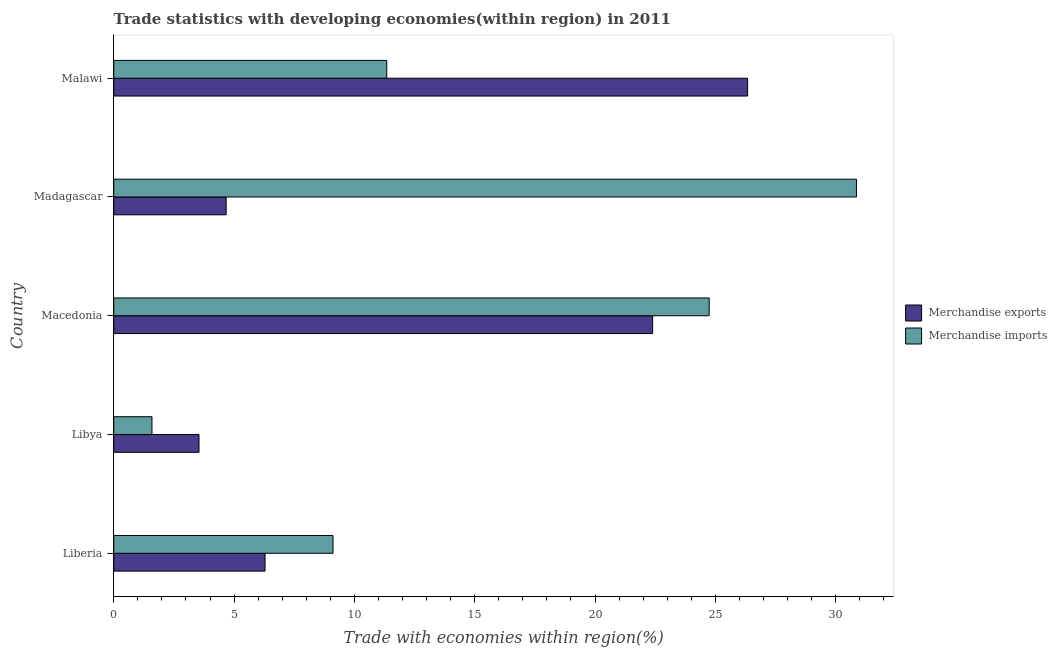How many groups of bars are there?
Make the answer very short. 5. Are the number of bars on each tick of the Y-axis equal?
Offer a terse response. Yes. What is the label of the 4th group of bars from the top?
Ensure brevity in your answer.  Libya. In how many cases, is the number of bars for a given country not equal to the number of legend labels?
Your answer should be very brief. 0. What is the merchandise imports in Malawi?
Your answer should be very brief. 11.35. Across all countries, what is the maximum merchandise imports?
Your answer should be very brief. 30.87. Across all countries, what is the minimum merchandise imports?
Provide a succinct answer. 1.59. In which country was the merchandise exports maximum?
Offer a very short reply. Malawi. In which country was the merchandise exports minimum?
Offer a terse response. Libya. What is the total merchandise exports in the graph?
Offer a terse response. 63.24. What is the difference between the merchandise exports in Liberia and that in Madagascar?
Offer a very short reply. 1.62. What is the difference between the merchandise exports in Libya and the merchandise imports in Macedonia?
Offer a very short reply. -21.2. What is the average merchandise exports per country?
Your answer should be compact. 12.65. What is the difference between the merchandise imports and merchandise exports in Macedonia?
Your response must be concise. 2.35. In how many countries, is the merchandise exports greater than 16 %?
Your response must be concise. 2. What is the ratio of the merchandise imports in Libya to that in Malawi?
Make the answer very short. 0.14. Is the merchandise imports in Libya less than that in Madagascar?
Provide a succinct answer. Yes. What is the difference between the highest and the second highest merchandise imports?
Your answer should be very brief. 6.12. What is the difference between the highest and the lowest merchandise imports?
Provide a succinct answer. 29.28. In how many countries, is the merchandise imports greater than the average merchandise imports taken over all countries?
Your response must be concise. 2. Is the sum of the merchandise exports in Liberia and Libya greater than the maximum merchandise imports across all countries?
Ensure brevity in your answer.  No. What does the 1st bar from the bottom in Madagascar represents?
Keep it short and to the point. Merchandise exports. How many countries are there in the graph?
Keep it short and to the point. 5. Are the values on the major ticks of X-axis written in scientific E-notation?
Your answer should be very brief. No. Does the graph contain grids?
Your answer should be compact. No. Where does the legend appear in the graph?
Provide a succinct answer. Center right. How many legend labels are there?
Offer a terse response. 2. How are the legend labels stacked?
Make the answer very short. Vertical. What is the title of the graph?
Provide a short and direct response. Trade statistics with developing economies(within region) in 2011. What is the label or title of the X-axis?
Your answer should be compact. Trade with economies within region(%). What is the label or title of the Y-axis?
Your answer should be compact. Country. What is the Trade with economies within region(%) of Merchandise exports in Liberia?
Give a very brief answer. 6.29. What is the Trade with economies within region(%) of Merchandise imports in Liberia?
Provide a short and direct response. 9.11. What is the Trade with economies within region(%) of Merchandise exports in Libya?
Make the answer very short. 3.54. What is the Trade with economies within region(%) of Merchandise imports in Libya?
Make the answer very short. 1.59. What is the Trade with economies within region(%) of Merchandise exports in Macedonia?
Give a very brief answer. 22.39. What is the Trade with economies within region(%) of Merchandise imports in Macedonia?
Provide a succinct answer. 24.75. What is the Trade with economies within region(%) of Merchandise exports in Madagascar?
Make the answer very short. 4.67. What is the Trade with economies within region(%) in Merchandise imports in Madagascar?
Offer a terse response. 30.87. What is the Trade with economies within region(%) of Merchandise exports in Malawi?
Your response must be concise. 26.34. What is the Trade with economies within region(%) in Merchandise imports in Malawi?
Provide a short and direct response. 11.35. Across all countries, what is the maximum Trade with economies within region(%) of Merchandise exports?
Offer a very short reply. 26.34. Across all countries, what is the maximum Trade with economies within region(%) in Merchandise imports?
Offer a terse response. 30.87. Across all countries, what is the minimum Trade with economies within region(%) of Merchandise exports?
Make the answer very short. 3.54. Across all countries, what is the minimum Trade with economies within region(%) of Merchandise imports?
Provide a short and direct response. 1.59. What is the total Trade with economies within region(%) of Merchandise exports in the graph?
Give a very brief answer. 63.24. What is the total Trade with economies within region(%) in Merchandise imports in the graph?
Make the answer very short. 77.66. What is the difference between the Trade with economies within region(%) of Merchandise exports in Liberia and that in Libya?
Your answer should be compact. 2.74. What is the difference between the Trade with economies within region(%) in Merchandise imports in Liberia and that in Libya?
Ensure brevity in your answer.  7.52. What is the difference between the Trade with economies within region(%) in Merchandise exports in Liberia and that in Macedonia?
Offer a terse response. -16.11. What is the difference between the Trade with economies within region(%) in Merchandise imports in Liberia and that in Macedonia?
Provide a succinct answer. -15.63. What is the difference between the Trade with economies within region(%) in Merchandise exports in Liberia and that in Madagascar?
Offer a very short reply. 1.62. What is the difference between the Trade with economies within region(%) in Merchandise imports in Liberia and that in Madagascar?
Make the answer very short. -21.75. What is the difference between the Trade with economies within region(%) in Merchandise exports in Liberia and that in Malawi?
Give a very brief answer. -20.05. What is the difference between the Trade with economies within region(%) in Merchandise imports in Liberia and that in Malawi?
Keep it short and to the point. -2.23. What is the difference between the Trade with economies within region(%) of Merchandise exports in Libya and that in Macedonia?
Provide a succinct answer. -18.85. What is the difference between the Trade with economies within region(%) of Merchandise imports in Libya and that in Macedonia?
Your answer should be compact. -23.16. What is the difference between the Trade with economies within region(%) of Merchandise exports in Libya and that in Madagascar?
Offer a very short reply. -1.13. What is the difference between the Trade with economies within region(%) in Merchandise imports in Libya and that in Madagascar?
Keep it short and to the point. -29.28. What is the difference between the Trade with economies within region(%) of Merchandise exports in Libya and that in Malawi?
Your answer should be compact. -22.8. What is the difference between the Trade with economies within region(%) of Merchandise imports in Libya and that in Malawi?
Make the answer very short. -9.76. What is the difference between the Trade with economies within region(%) in Merchandise exports in Macedonia and that in Madagascar?
Ensure brevity in your answer.  17.72. What is the difference between the Trade with economies within region(%) in Merchandise imports in Macedonia and that in Madagascar?
Provide a succinct answer. -6.12. What is the difference between the Trade with economies within region(%) of Merchandise exports in Macedonia and that in Malawi?
Ensure brevity in your answer.  -3.95. What is the difference between the Trade with economies within region(%) of Merchandise imports in Macedonia and that in Malawi?
Provide a short and direct response. 13.4. What is the difference between the Trade with economies within region(%) in Merchandise exports in Madagascar and that in Malawi?
Provide a succinct answer. -21.67. What is the difference between the Trade with economies within region(%) of Merchandise imports in Madagascar and that in Malawi?
Provide a succinct answer. 19.52. What is the difference between the Trade with economies within region(%) of Merchandise exports in Liberia and the Trade with economies within region(%) of Merchandise imports in Libya?
Your answer should be compact. 4.7. What is the difference between the Trade with economies within region(%) in Merchandise exports in Liberia and the Trade with economies within region(%) in Merchandise imports in Macedonia?
Give a very brief answer. -18.46. What is the difference between the Trade with economies within region(%) of Merchandise exports in Liberia and the Trade with economies within region(%) of Merchandise imports in Madagascar?
Offer a very short reply. -24.58. What is the difference between the Trade with economies within region(%) of Merchandise exports in Liberia and the Trade with economies within region(%) of Merchandise imports in Malawi?
Provide a short and direct response. -5.06. What is the difference between the Trade with economies within region(%) in Merchandise exports in Libya and the Trade with economies within region(%) in Merchandise imports in Macedonia?
Give a very brief answer. -21.2. What is the difference between the Trade with economies within region(%) in Merchandise exports in Libya and the Trade with economies within region(%) in Merchandise imports in Madagascar?
Provide a succinct answer. -27.32. What is the difference between the Trade with economies within region(%) in Merchandise exports in Libya and the Trade with economies within region(%) in Merchandise imports in Malawi?
Keep it short and to the point. -7.8. What is the difference between the Trade with economies within region(%) in Merchandise exports in Macedonia and the Trade with economies within region(%) in Merchandise imports in Madagascar?
Offer a very short reply. -8.47. What is the difference between the Trade with economies within region(%) in Merchandise exports in Macedonia and the Trade with economies within region(%) in Merchandise imports in Malawi?
Your answer should be compact. 11.05. What is the difference between the Trade with economies within region(%) in Merchandise exports in Madagascar and the Trade with economies within region(%) in Merchandise imports in Malawi?
Provide a succinct answer. -6.67. What is the average Trade with economies within region(%) in Merchandise exports per country?
Ensure brevity in your answer.  12.65. What is the average Trade with economies within region(%) of Merchandise imports per country?
Keep it short and to the point. 15.53. What is the difference between the Trade with economies within region(%) in Merchandise exports and Trade with economies within region(%) in Merchandise imports in Liberia?
Provide a short and direct response. -2.83. What is the difference between the Trade with economies within region(%) in Merchandise exports and Trade with economies within region(%) in Merchandise imports in Libya?
Make the answer very short. 1.95. What is the difference between the Trade with economies within region(%) of Merchandise exports and Trade with economies within region(%) of Merchandise imports in Macedonia?
Your response must be concise. -2.35. What is the difference between the Trade with economies within region(%) of Merchandise exports and Trade with economies within region(%) of Merchandise imports in Madagascar?
Provide a short and direct response. -26.19. What is the difference between the Trade with economies within region(%) in Merchandise exports and Trade with economies within region(%) in Merchandise imports in Malawi?
Make the answer very short. 14.99. What is the ratio of the Trade with economies within region(%) of Merchandise exports in Liberia to that in Libya?
Offer a terse response. 1.77. What is the ratio of the Trade with economies within region(%) of Merchandise imports in Liberia to that in Libya?
Make the answer very short. 5.74. What is the ratio of the Trade with economies within region(%) in Merchandise exports in Liberia to that in Macedonia?
Provide a short and direct response. 0.28. What is the ratio of the Trade with economies within region(%) of Merchandise imports in Liberia to that in Macedonia?
Your answer should be very brief. 0.37. What is the ratio of the Trade with economies within region(%) of Merchandise exports in Liberia to that in Madagascar?
Make the answer very short. 1.35. What is the ratio of the Trade with economies within region(%) in Merchandise imports in Liberia to that in Madagascar?
Make the answer very short. 0.3. What is the ratio of the Trade with economies within region(%) in Merchandise exports in Liberia to that in Malawi?
Make the answer very short. 0.24. What is the ratio of the Trade with economies within region(%) of Merchandise imports in Liberia to that in Malawi?
Offer a terse response. 0.8. What is the ratio of the Trade with economies within region(%) of Merchandise exports in Libya to that in Macedonia?
Offer a very short reply. 0.16. What is the ratio of the Trade with economies within region(%) in Merchandise imports in Libya to that in Macedonia?
Give a very brief answer. 0.06. What is the ratio of the Trade with economies within region(%) of Merchandise exports in Libya to that in Madagascar?
Your response must be concise. 0.76. What is the ratio of the Trade with economies within region(%) in Merchandise imports in Libya to that in Madagascar?
Ensure brevity in your answer.  0.05. What is the ratio of the Trade with economies within region(%) of Merchandise exports in Libya to that in Malawi?
Your response must be concise. 0.13. What is the ratio of the Trade with economies within region(%) in Merchandise imports in Libya to that in Malawi?
Offer a terse response. 0.14. What is the ratio of the Trade with economies within region(%) in Merchandise exports in Macedonia to that in Madagascar?
Make the answer very short. 4.79. What is the ratio of the Trade with economies within region(%) of Merchandise imports in Macedonia to that in Madagascar?
Your answer should be compact. 0.8. What is the ratio of the Trade with economies within region(%) in Merchandise exports in Macedonia to that in Malawi?
Your answer should be very brief. 0.85. What is the ratio of the Trade with economies within region(%) in Merchandise imports in Macedonia to that in Malawi?
Your answer should be very brief. 2.18. What is the ratio of the Trade with economies within region(%) in Merchandise exports in Madagascar to that in Malawi?
Provide a short and direct response. 0.18. What is the ratio of the Trade with economies within region(%) in Merchandise imports in Madagascar to that in Malawi?
Give a very brief answer. 2.72. What is the difference between the highest and the second highest Trade with economies within region(%) of Merchandise exports?
Give a very brief answer. 3.95. What is the difference between the highest and the second highest Trade with economies within region(%) in Merchandise imports?
Your response must be concise. 6.12. What is the difference between the highest and the lowest Trade with economies within region(%) in Merchandise exports?
Give a very brief answer. 22.8. What is the difference between the highest and the lowest Trade with economies within region(%) in Merchandise imports?
Your answer should be compact. 29.28. 